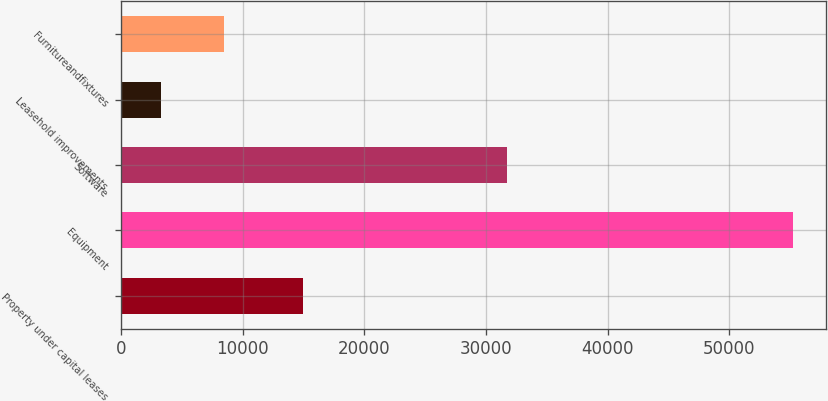Convert chart. <chart><loc_0><loc_0><loc_500><loc_500><bar_chart><fcel>Property under capital leases<fcel>Equipment<fcel>Software<fcel>Leasehold improvements<fcel>Furnitureandfixtures<nl><fcel>14989<fcel>55180<fcel>31694<fcel>3303<fcel>8490.7<nl></chart> 